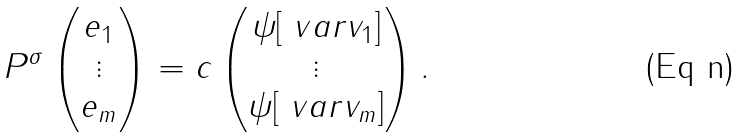<formula> <loc_0><loc_0><loc_500><loc_500>P ^ { \sigma } \begin{pmatrix} e _ { 1 } \\ \vdots \\ e _ { m } \end{pmatrix} = c \begin{pmatrix} \psi [ \ v a r v _ { 1 } ] \\ \vdots \\ \psi [ \ v a r v _ { m } ] \end{pmatrix} .</formula> 